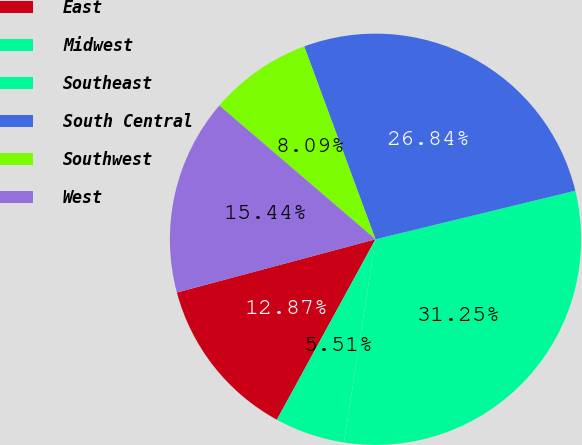Convert chart to OTSL. <chart><loc_0><loc_0><loc_500><loc_500><pie_chart><fcel>East<fcel>Midwest<fcel>Southeast<fcel>South Central<fcel>Southwest<fcel>West<nl><fcel>12.87%<fcel>5.51%<fcel>31.25%<fcel>26.84%<fcel>8.09%<fcel>15.44%<nl></chart> 